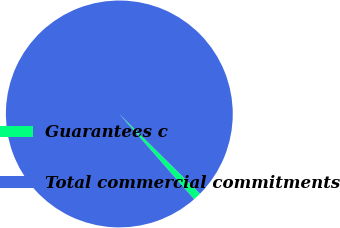<chart> <loc_0><loc_0><loc_500><loc_500><pie_chart><fcel>Guarantees c<fcel>Total commercial commitments<nl><fcel>1.13%<fcel>98.87%<nl></chart> 